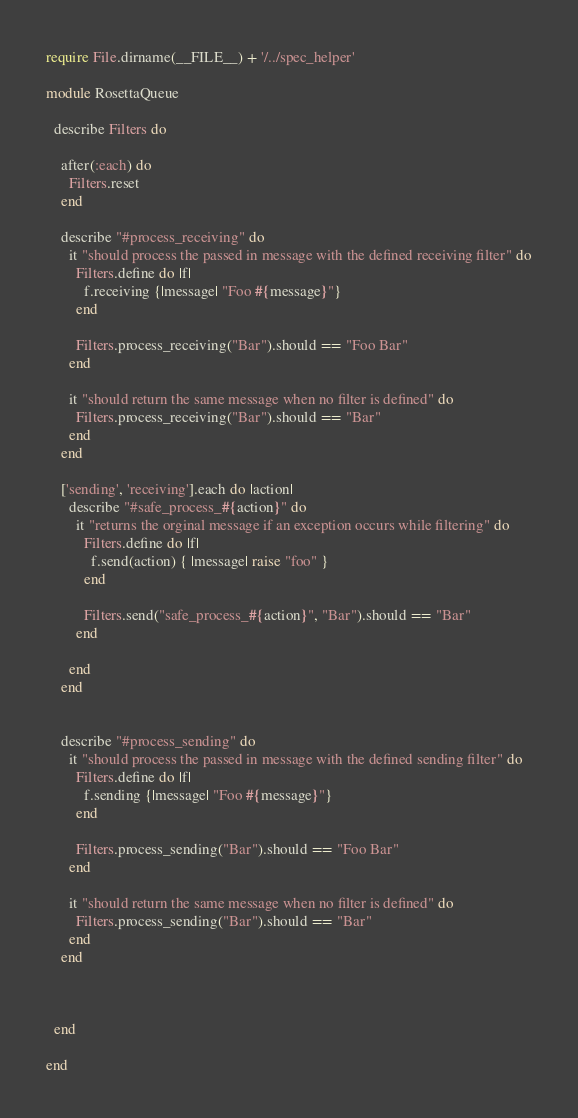Convert code to text. <code><loc_0><loc_0><loc_500><loc_500><_Ruby_>require File.dirname(__FILE__) + '/../spec_helper'

module RosettaQueue

  describe Filters do

    after(:each) do
      Filters.reset
    end

    describe "#process_receiving" do
      it "should process the passed in message with the defined receiving filter" do
        Filters.define do |f|
          f.receiving {|message| "Foo #{message}"}
        end

        Filters.process_receiving("Bar").should == "Foo Bar"
      end

      it "should return the same message when no filter is defined" do
        Filters.process_receiving("Bar").should == "Bar"
      end
    end

    ['sending', 'receiving'].each do |action|
      describe "#safe_process_#{action}" do
        it "returns the orginal message if an exception occurs while filtering" do
          Filters.define do |f|
            f.send(action) { |message| raise "foo" }
          end

          Filters.send("safe_process_#{action}", "Bar").should == "Bar"
        end

      end
    end


    describe "#process_sending" do
      it "should process the passed in message with the defined sending filter" do
        Filters.define do |f|
          f.sending {|message| "Foo #{message}"}
        end

        Filters.process_sending("Bar").should == "Foo Bar"
      end

      it "should return the same message when no filter is defined" do
        Filters.process_sending("Bar").should == "Bar"
      end
    end



  end

end
</code> 